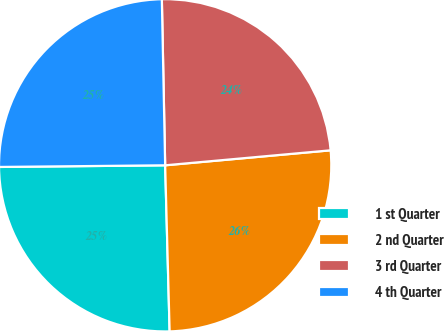Convert chart to OTSL. <chart><loc_0><loc_0><loc_500><loc_500><pie_chart><fcel>1 st Quarter<fcel>2 nd Quarter<fcel>3 rd Quarter<fcel>4 th Quarter<nl><fcel>25.27%<fcel>26.01%<fcel>23.88%<fcel>24.84%<nl></chart> 